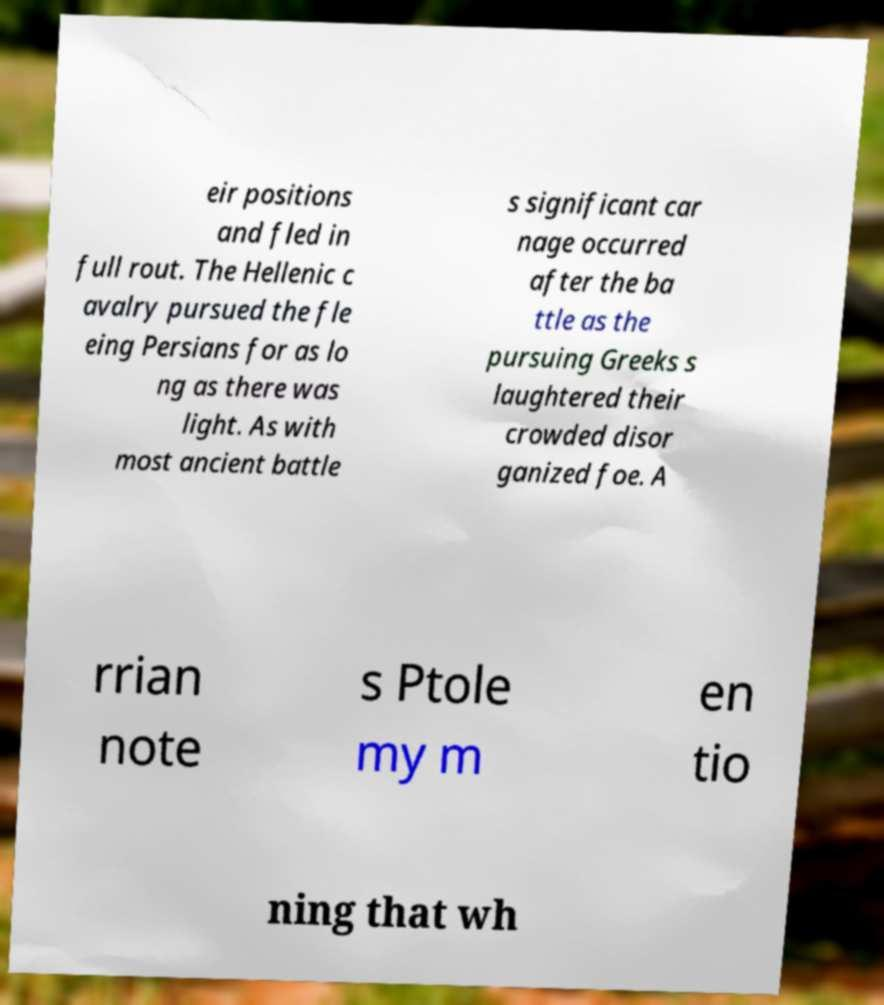What messages or text are displayed in this image? I need them in a readable, typed format. eir positions and fled in full rout. The Hellenic c avalry pursued the fle eing Persians for as lo ng as there was light. As with most ancient battle s significant car nage occurred after the ba ttle as the pursuing Greeks s laughtered their crowded disor ganized foe. A rrian note s Ptole my m en tio ning that wh 